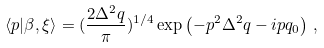Convert formula to latex. <formula><loc_0><loc_0><loc_500><loc_500>\langle p | \beta , \xi \rangle = ( \frac { 2 \Delta ^ { 2 } q } { \pi } ) ^ { 1 / 4 } \exp \left ( - p ^ { 2 } \Delta ^ { 2 } q - i p q _ { 0 } \right ) \, ,</formula> 